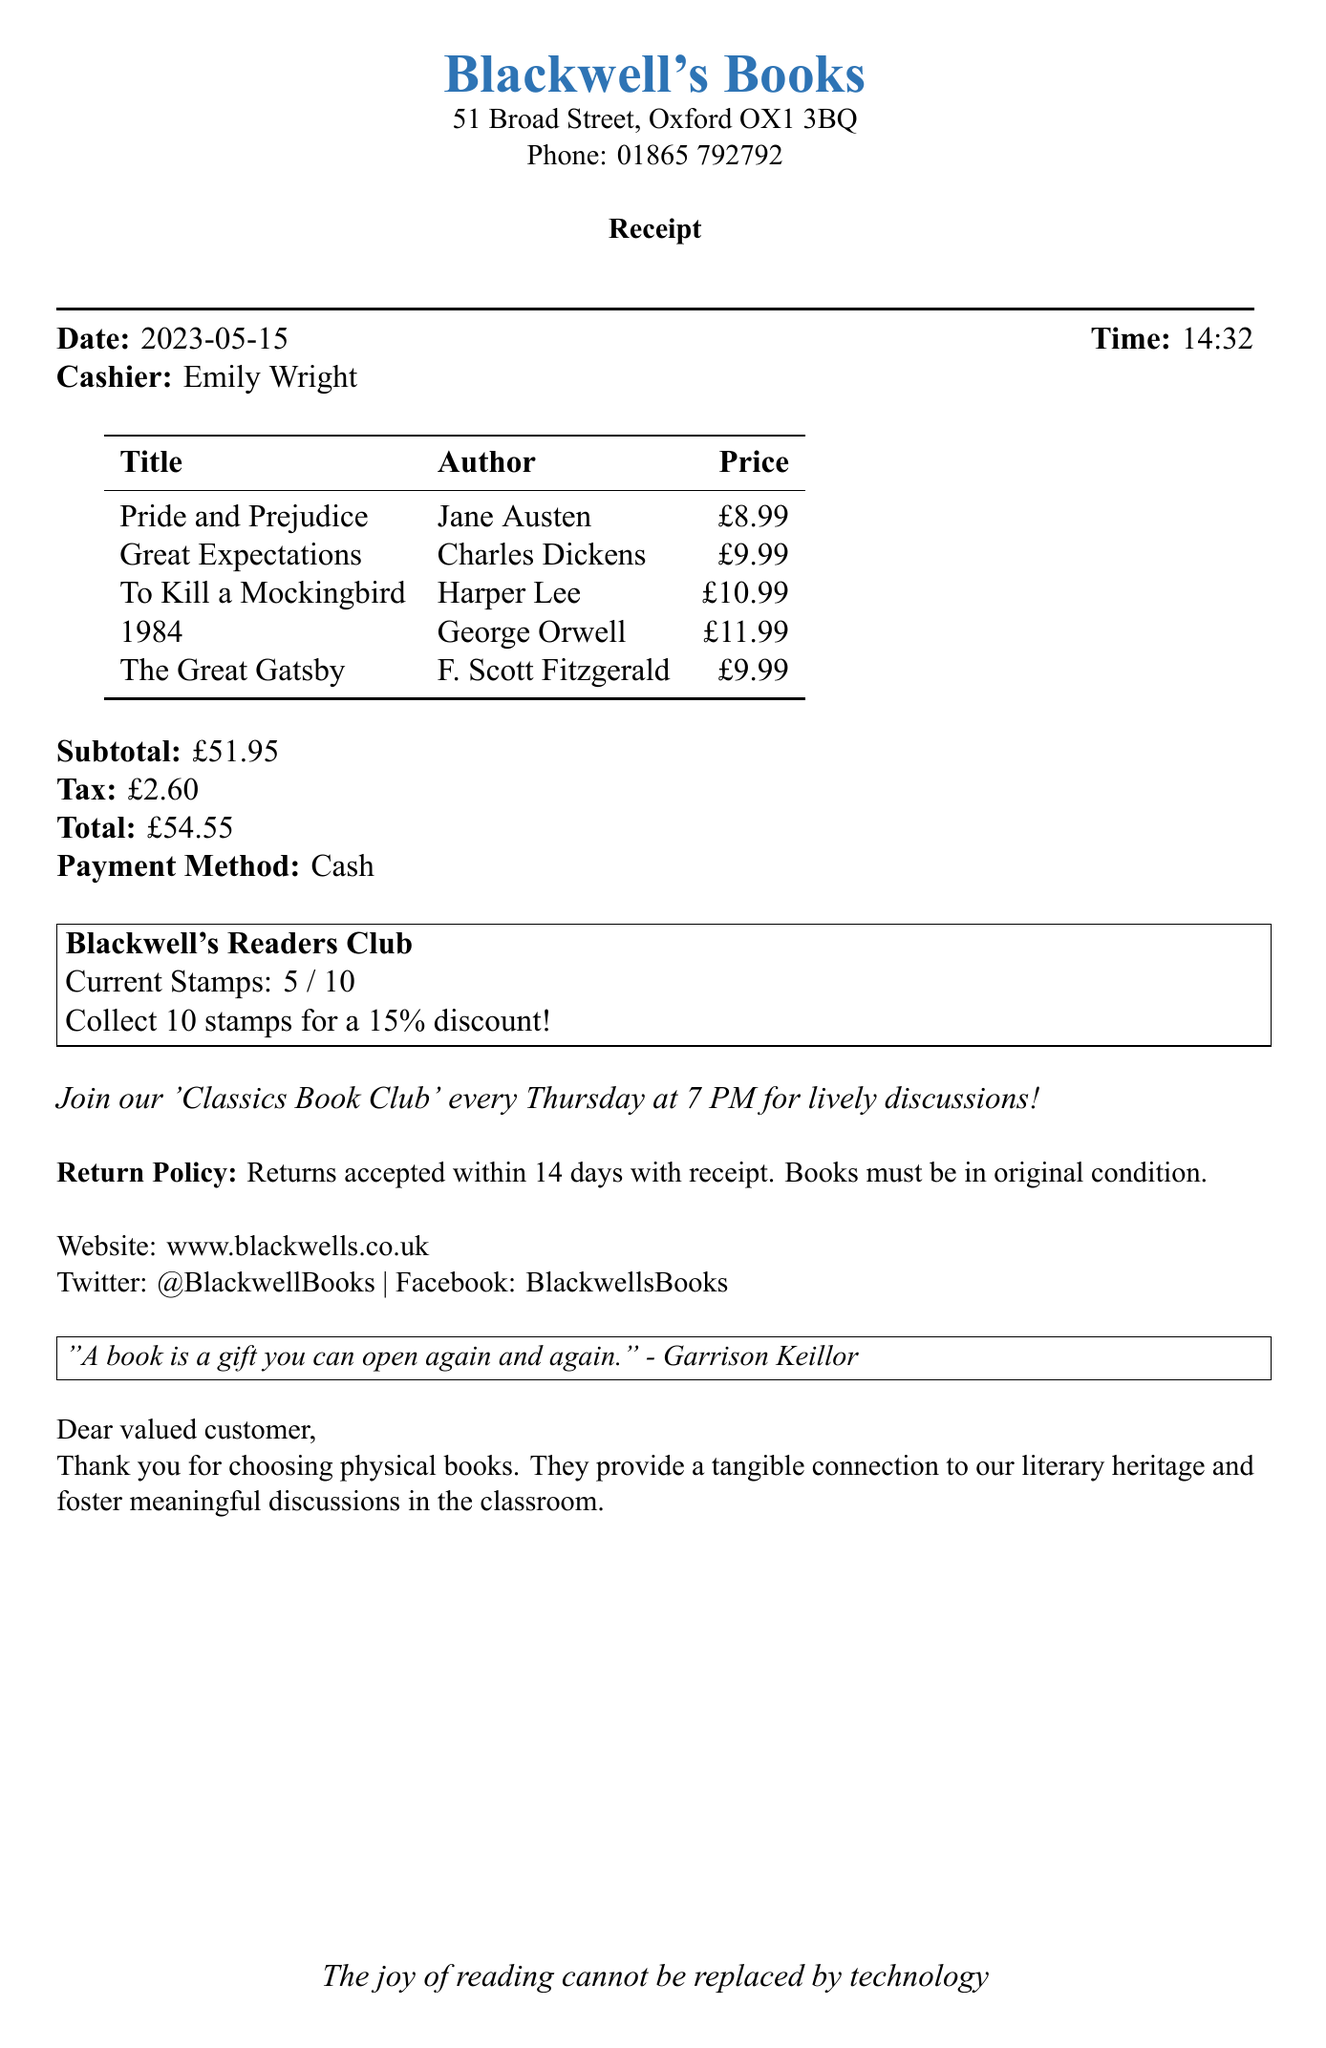What is the name of the bookstore? The document specifies the name of the bookstore at the top of the receipt.
Answer: Blackwell's Books Who was the cashier at the time of the purchase? The cashier's name is mentioned in the receipt details.
Answer: Emily Wright How many stamps does the customer currently have? The document states the current stamps collected by the customer in the loyalty program section.
Answer: 5 What is the total amount paid for the books? The total amount is indicated at the end of the receipt, summarizing the cost.
Answer: £54.55 What is the discount percentage offered in the loyalty program? The receipt provides information about the discount available after collecting stamps.
Answer: 15% When was the purchase made? The date of the transaction is specified at the top of the receipt.
Answer: 2023-05-15 What is the educational quote included in the receipt? The document features a quote related to books, emphasizing their value.
Answer: "A book is a gift you can open again and again." What is the return policy for the books? The return policy is explicitly stated within the receipt's details.
Answer: Returns accepted within 14 days with receipt What is the time of the transaction? The receipt includes the time when the transaction occurred.
Answer: 14:32 What special event is mentioned on the receipt? The document promotes a specific event related to the bookstore's offerings.
Answer: 'Classics Book Club' every Thursday at 7 PM 